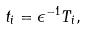<formula> <loc_0><loc_0><loc_500><loc_500>t _ { i } = \epsilon ^ { - 1 } T _ { i } ,</formula> 